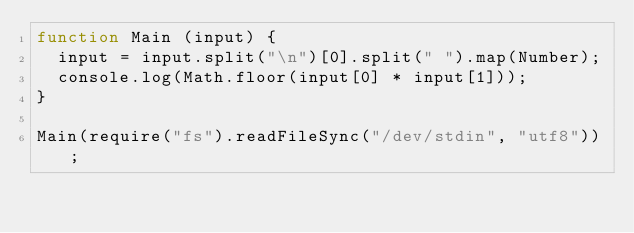Convert code to text. <code><loc_0><loc_0><loc_500><loc_500><_JavaScript_>function Main (input) {
  input = input.split("\n")[0].split(" ").map(Number);
  console.log(Math.floor(input[0] * input[1]));
}

Main(require("fs").readFileSync("/dev/stdin", "utf8"));</code> 